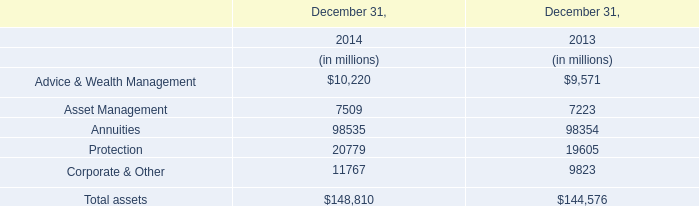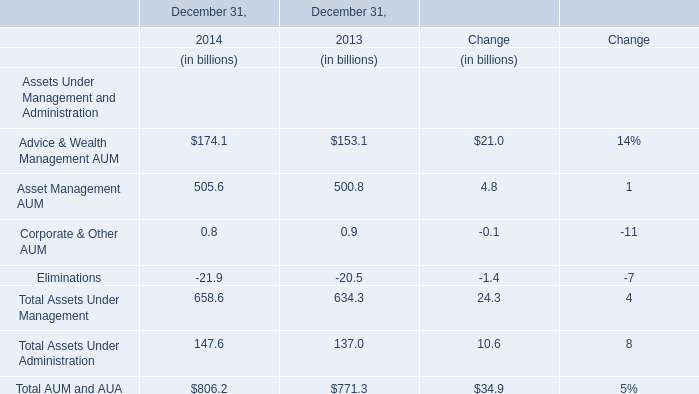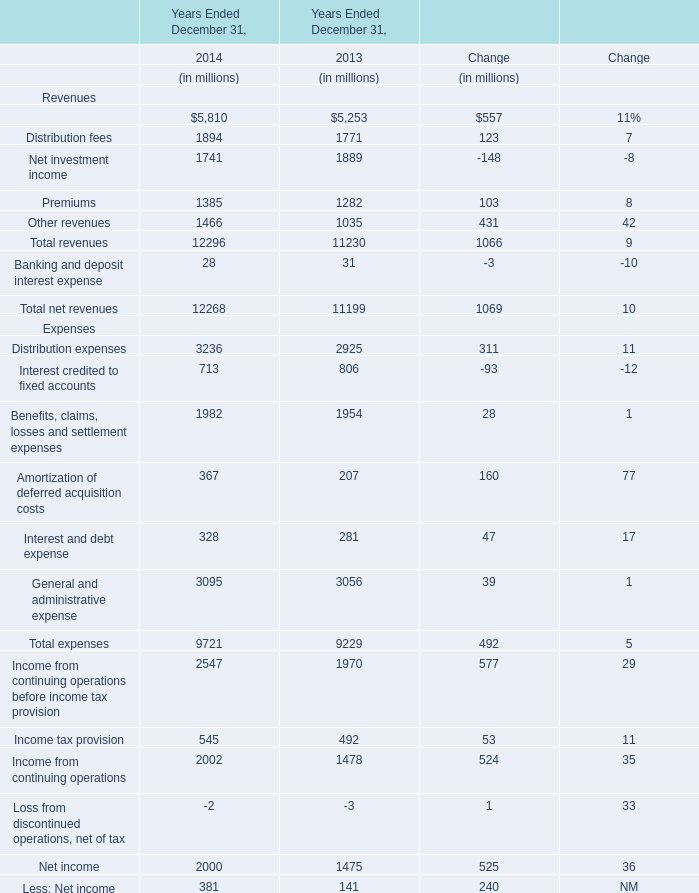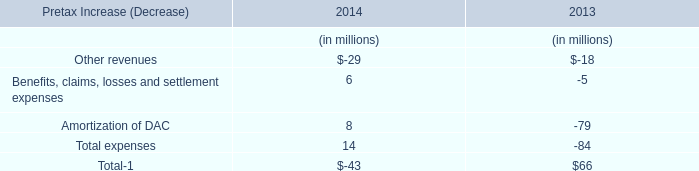What's the growth rate of Premiums in 2014? (in %) 
Answer: 8. 